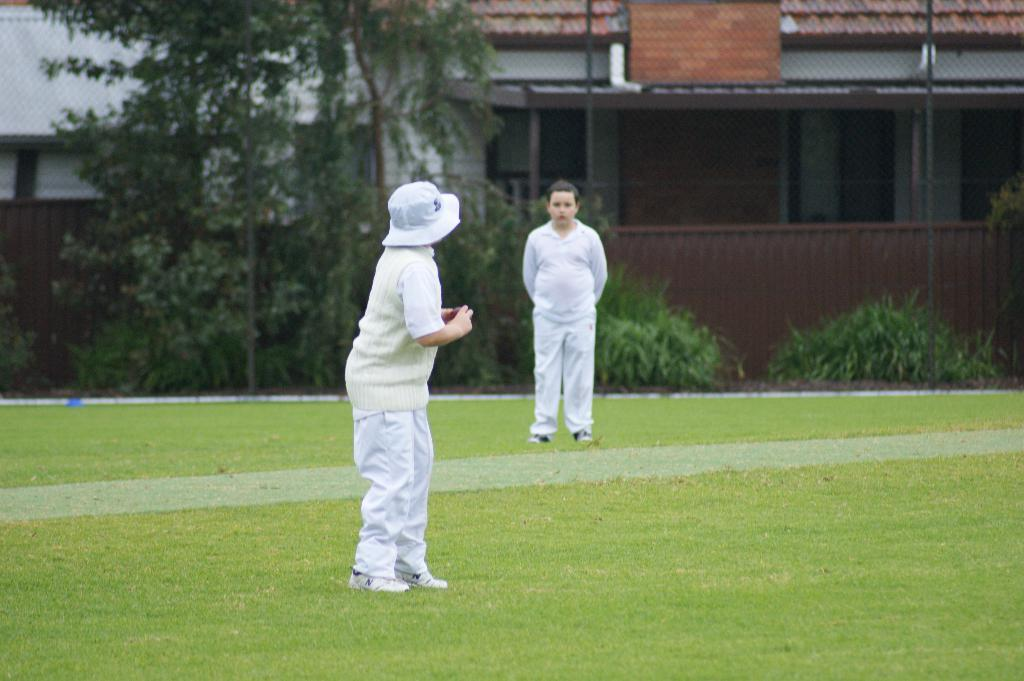How many kids are in the image? There are two kids standing in the image. What is one of the kids holding? One of the kids is holding a ball. What type of surface is visible under the kids' feet? There is grass visible in the image. What can be seen in the distance behind the kids? There are trees, plants, a fence, a board, and a house in the background of the image. What type of cord is hanging from the tree in the image? There is no cord hanging from a tree in the image; there are only trees, plants, a fence, a board, and a house visible in the background. 